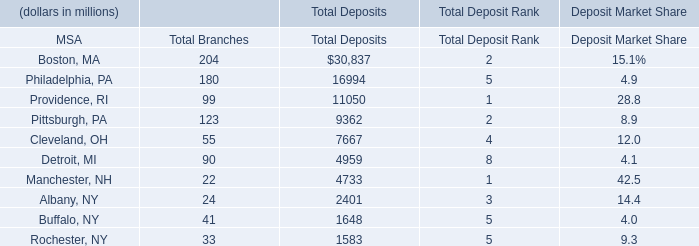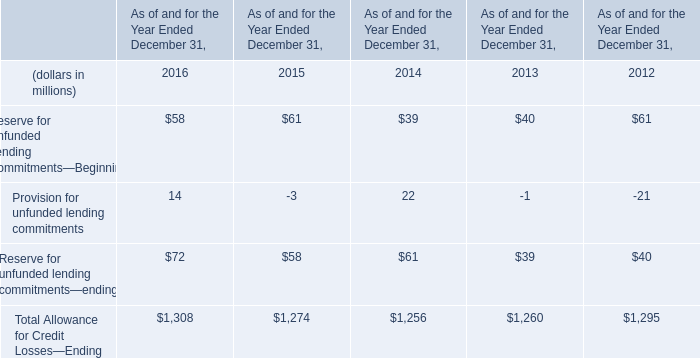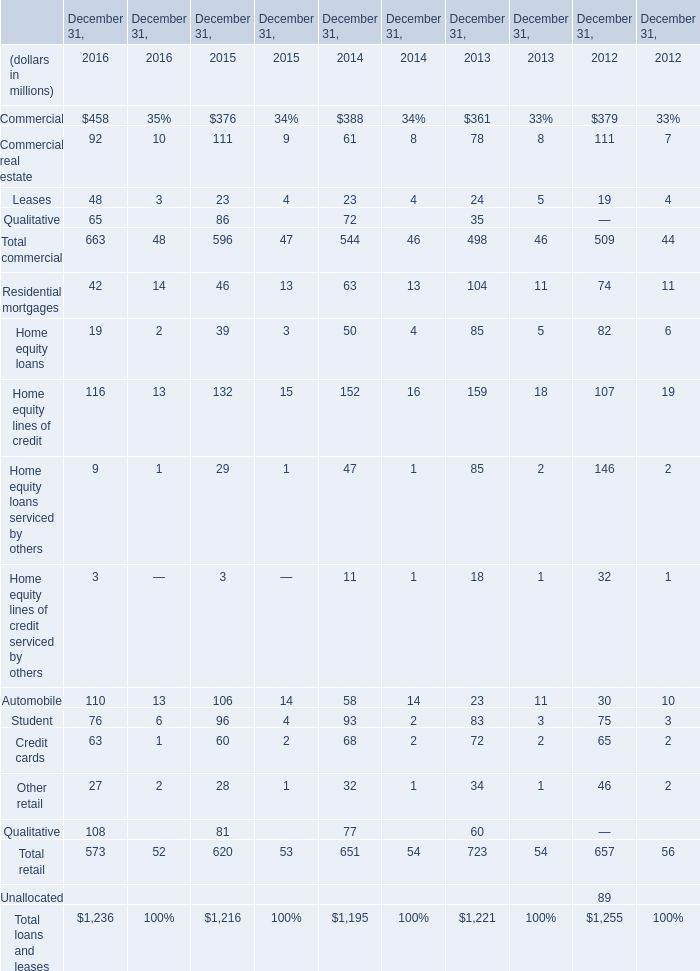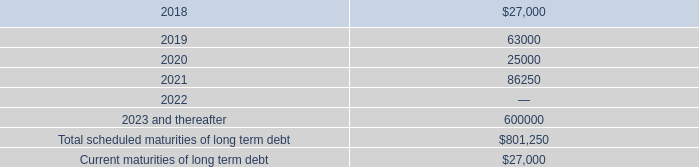Which year is Reserve for Unfunded Lending Commitments—Beginning the least? 
Answer: 2014. 